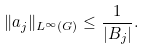<formula> <loc_0><loc_0><loc_500><loc_500>\| a _ { j } \| _ { L ^ { \infty } ( G ) } \leq \frac { 1 } { | B _ { j } | } .</formula> 